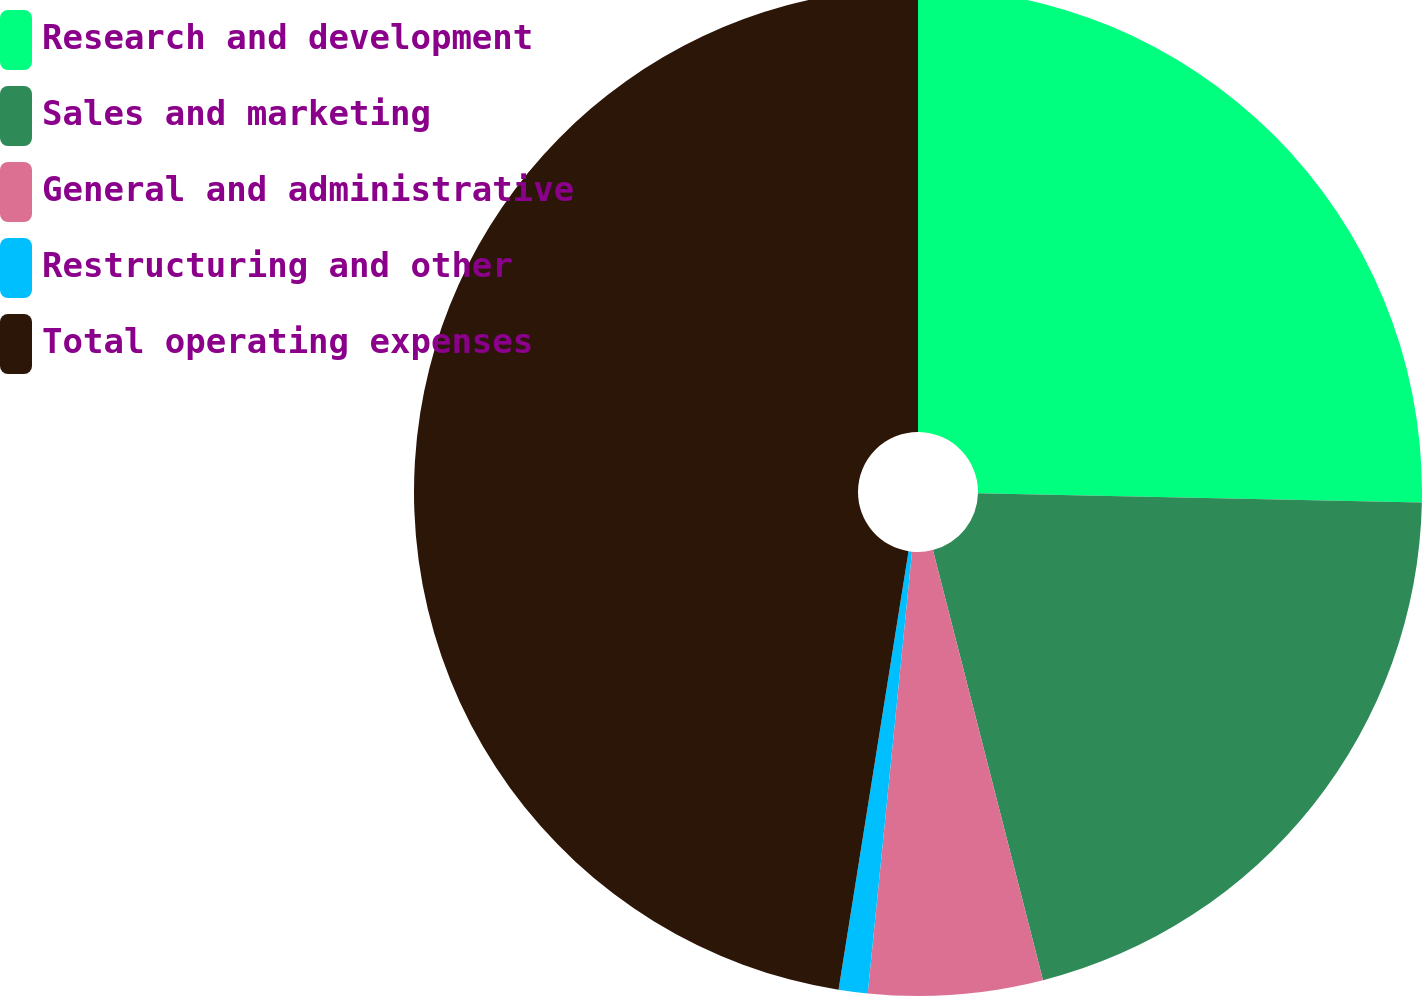<chart> <loc_0><loc_0><loc_500><loc_500><pie_chart><fcel>Research and development<fcel>Sales and marketing<fcel>General and administrative<fcel>Restructuring and other<fcel>Total operating expenses<nl><fcel>25.33%<fcel>20.68%<fcel>5.58%<fcel>0.93%<fcel>47.48%<nl></chart> 